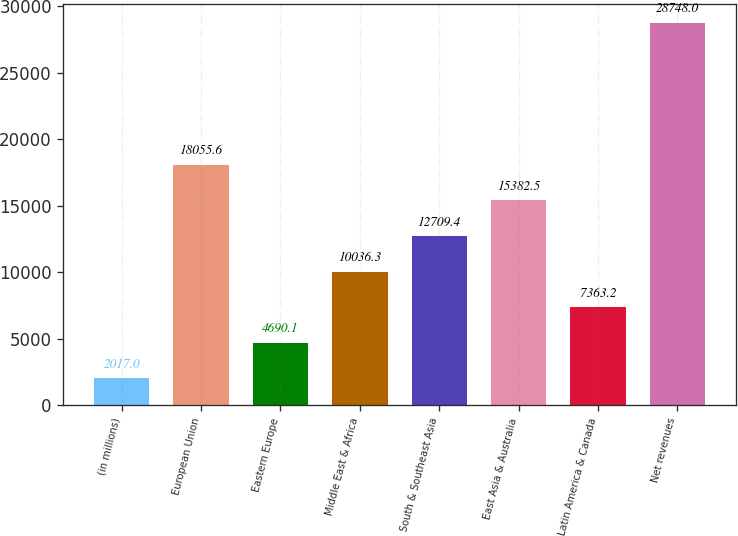Convert chart. <chart><loc_0><loc_0><loc_500><loc_500><bar_chart><fcel>(in millions)<fcel>European Union<fcel>Eastern Europe<fcel>Middle East & Africa<fcel>South & Southeast Asia<fcel>East Asia & Australia<fcel>Latin America & Canada<fcel>Net revenues<nl><fcel>2017<fcel>18055.6<fcel>4690.1<fcel>10036.3<fcel>12709.4<fcel>15382.5<fcel>7363.2<fcel>28748<nl></chart> 